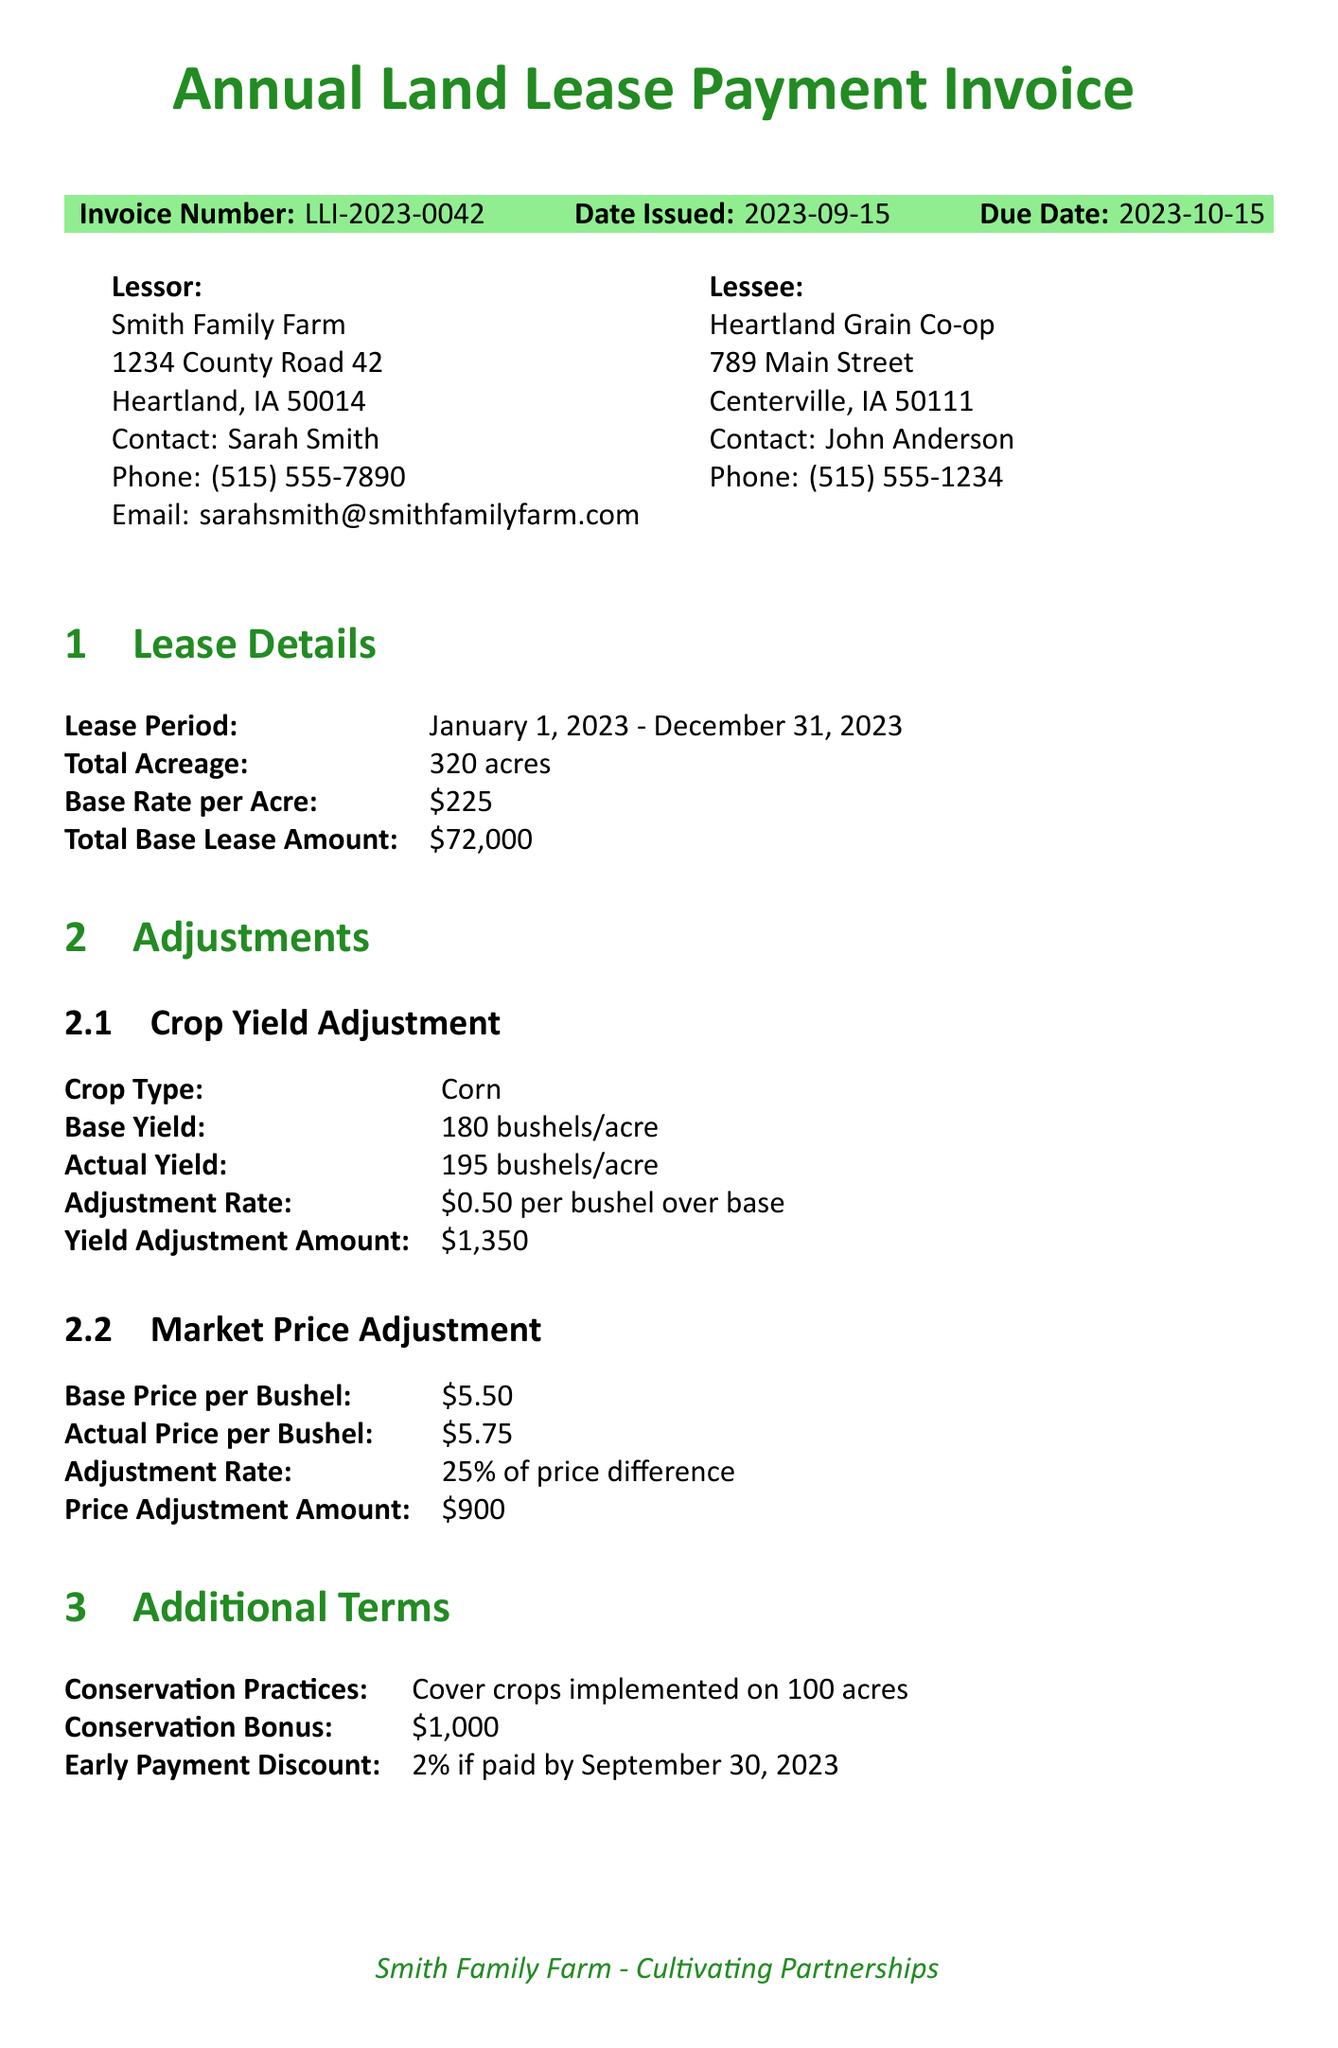What is the invoice number? The invoice number is specified in the document under the invoice details section.
Answer: LLI-2023-0042 Who is the lessor? The lessor's name is listed in the lessor info section of the document.
Answer: Smith Family Farm What is the total acreage? The total acreage is mentioned in the lease details section.
Answer: 320 acres What is the total due amount? The total due amount is calculated in the payment summary section.
Answer: $73,745 What is the early payment discount percentage? The early payment discount percentage is provided in the additional terms section.
Answer: 2% How much is the yield adjustment amount? The yield adjustment amount can be found in the crop yield adjustment subsection of the adjustments section.
Answer: $1,350 What practices were implemented on 100 acres? The document specifies conservation practices in the additional terms section.
Answer: Cover crops What is the late payment fee percentage? The late payment fee percentage is mentioned in the payment instructions section.
Answer: 1.5% Who should be contacted for questions regarding the invoice? The notes section indicates who to contact for any questions.
Answer: Sarah Smith 